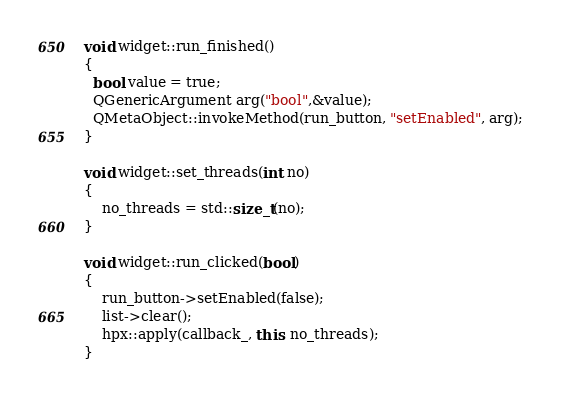Convert code to text. <code><loc_0><loc_0><loc_500><loc_500><_C++_>void widget::run_finished()
{
  bool value = true;
  QGenericArgument arg("bool",&value);
  QMetaObject::invokeMethod(run_button, "setEnabled", arg);
}

void widget::set_threads(int no)
{
    no_threads = std::size_t(no);
}

void widget::run_clicked(bool)
{
    run_button->setEnabled(false);
    list->clear();
    hpx::apply(callback_, this, no_threads);
}
</code> 